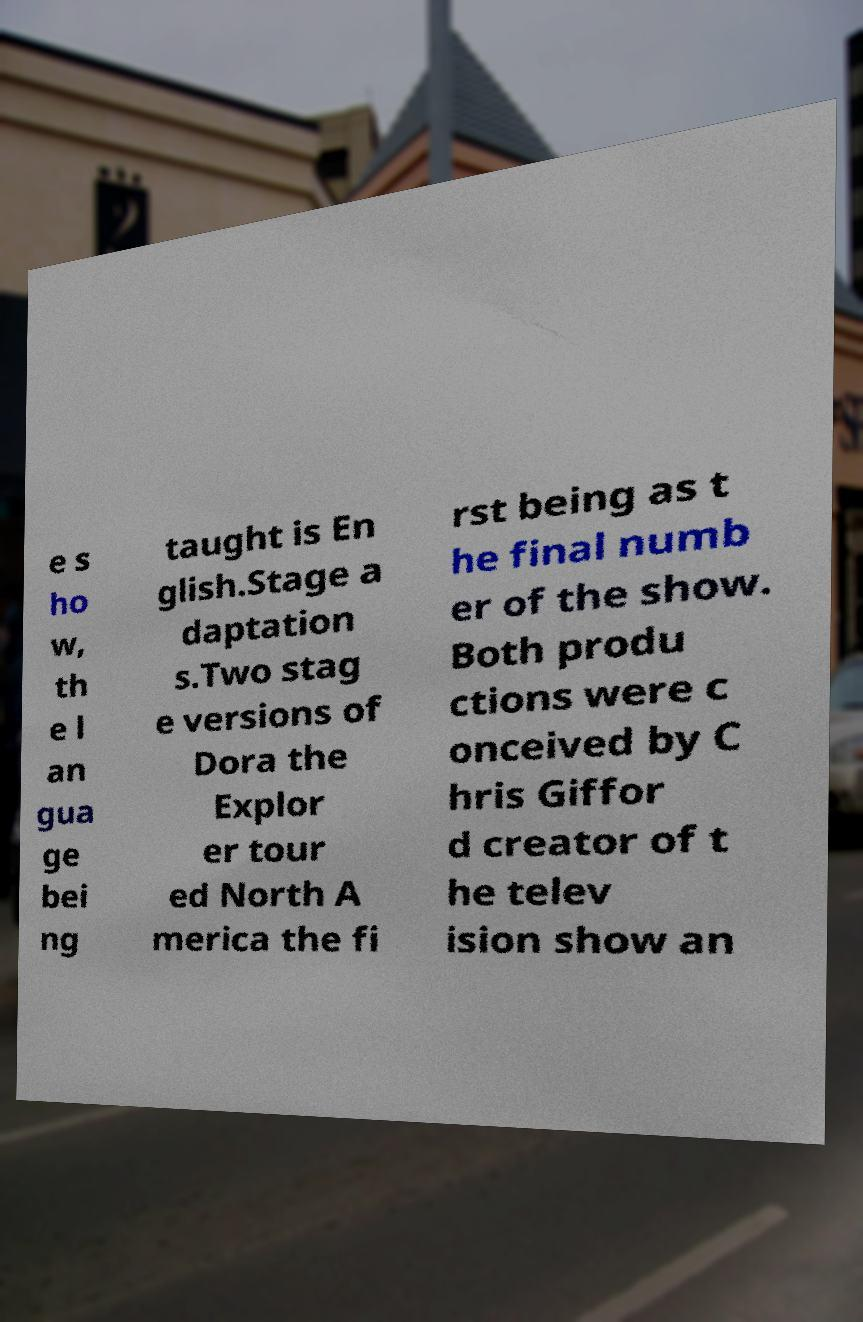Could you extract and type out the text from this image? e s ho w, th e l an gua ge bei ng taught is En glish.Stage a daptation s.Two stag e versions of Dora the Explor er tour ed North A merica the fi rst being as t he final numb er of the show. Both produ ctions were c onceived by C hris Giffor d creator of t he telev ision show an 